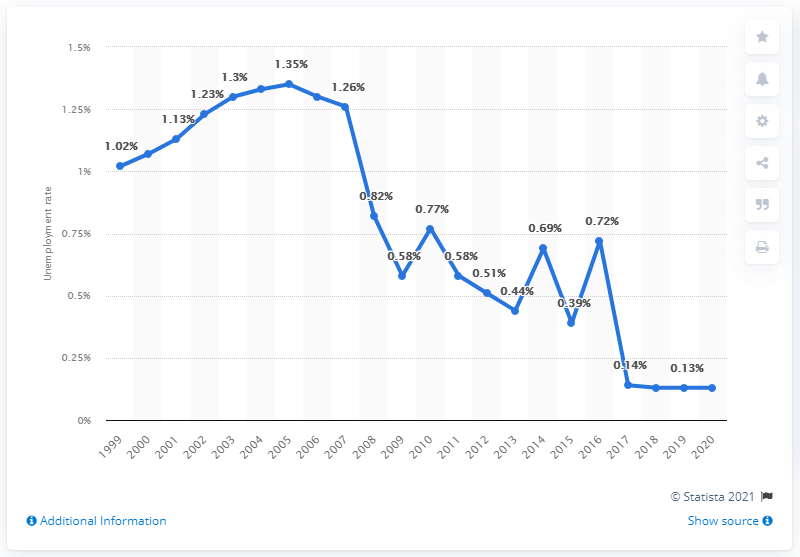Draw attention to some important aspects in this diagram. The unemployment rate in Cambodia in 2020 was 0.13%. 